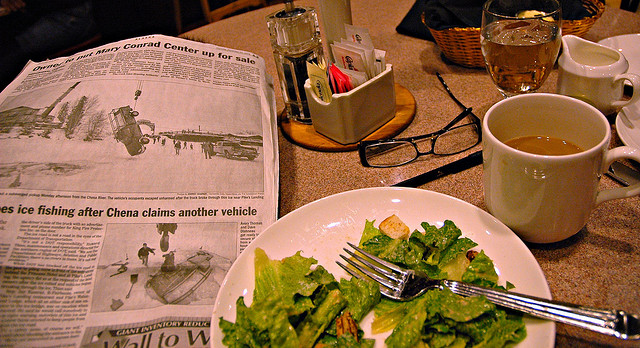Identify and read out the text in this image. Chena vechicle another claims W to ice after fishing sale for up Contor Conard 